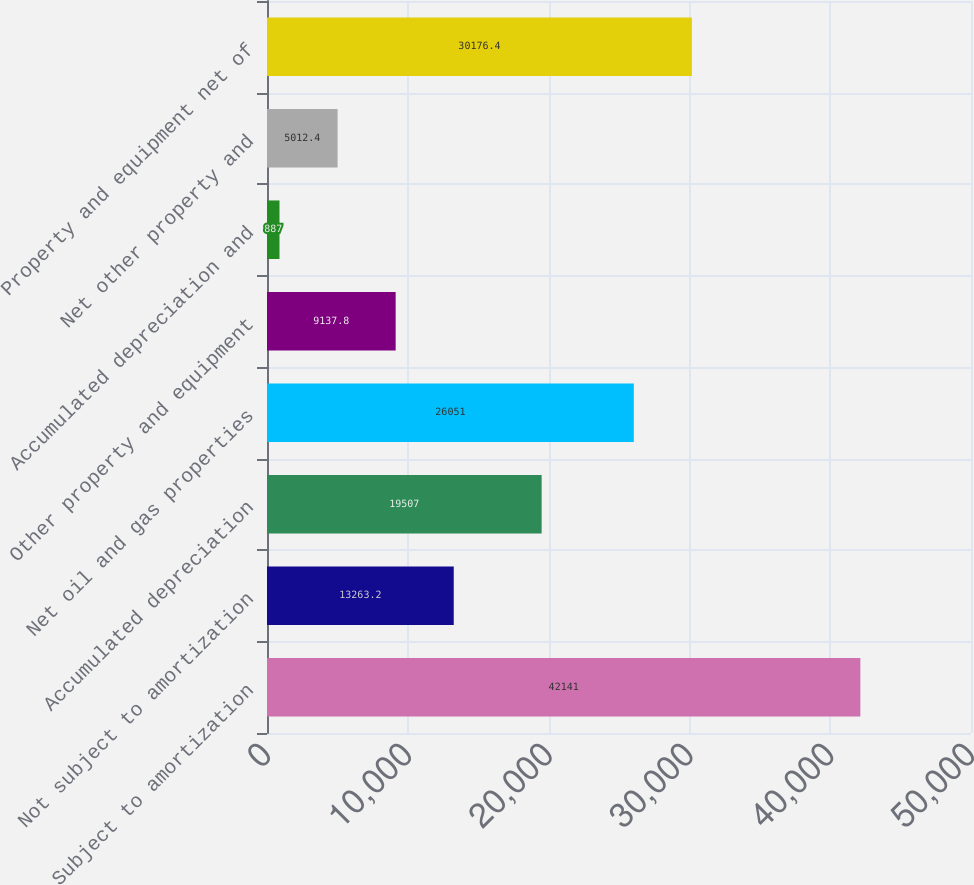<chart> <loc_0><loc_0><loc_500><loc_500><bar_chart><fcel>Subject to amortization<fcel>Not subject to amortization<fcel>Accumulated depreciation<fcel>Net oil and gas properties<fcel>Other property and equipment<fcel>Accumulated depreciation and<fcel>Net other property and<fcel>Property and equipment net of<nl><fcel>42141<fcel>13263.2<fcel>19507<fcel>26051<fcel>9137.8<fcel>887<fcel>5012.4<fcel>30176.4<nl></chart> 